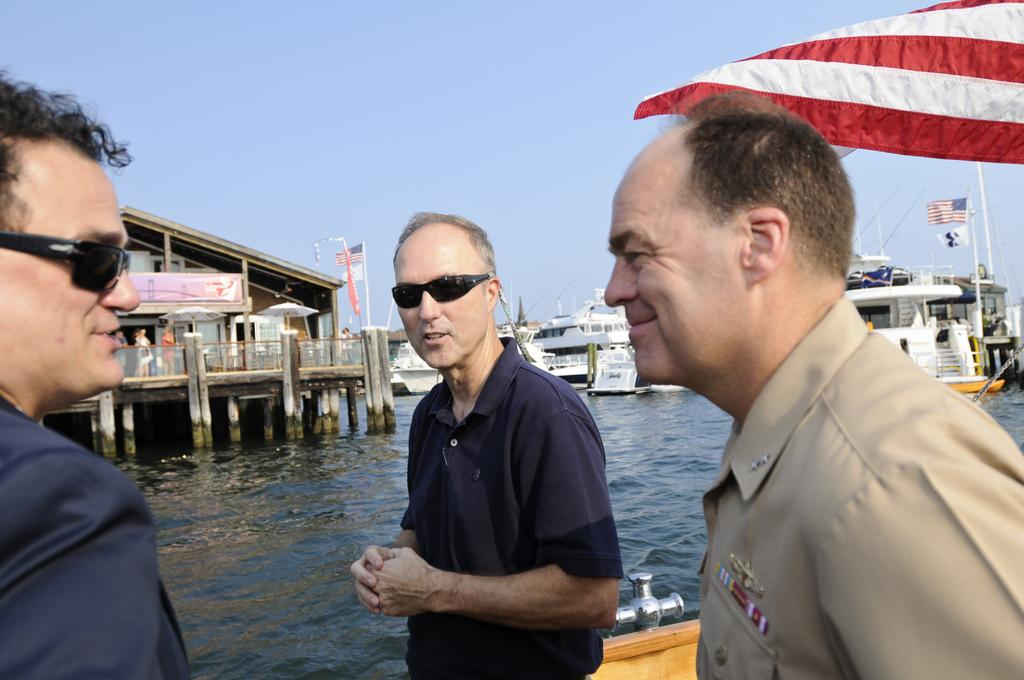What can be seen in the image involving people? There are people standing in the image. What type of vehicles are present in the image? There are ships in the image. What structures are visible in the image? There are houses in the image. Where are the ships and houses located? The ships and houses are on the water. What additional objects can be seen in the image? There are flags in the image. What part of the natural environment is visible in the image? The sky is visible in the image. What statement or note can be seen written on the ships in the image? There are no statements or notes visible on the ships in the image. What type of weather condition, such as fog, can be seen in the image? There is no fog visible in the image; the sky is visible. 